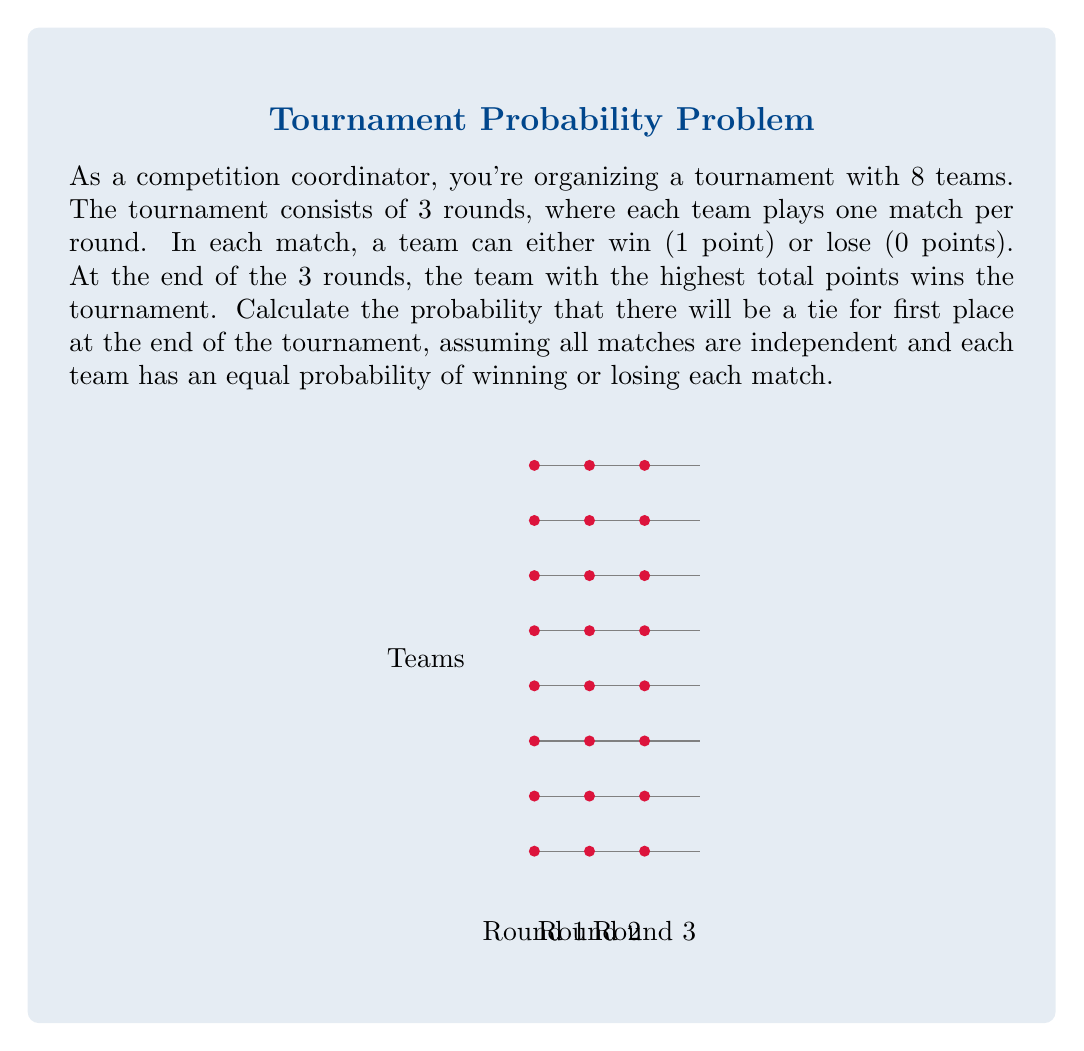Could you help me with this problem? Let's approach this step-by-step:

1) First, we need to understand the possible outcomes. After 3 rounds, a team can have 0, 1, 2, or 3 points.

2) For a tie to occur, at least two teams must have the highest score, and no team can have a higher score.

3) The probability of a team getting exactly k points in 3 rounds follows a binomial distribution:

   $P(X=k) = \binom{3}{k} (0.5)^3 = \binom{3}{k} (0.125)$

4) The probabilities for each outcome are:
   $P(0) = P(3) = 0.125$
   $P(1) = P(2) = 0.375$

5) Now, we need to consider the ways a tie can occur:
   - All teams tie with 3 points
   - All teams tie with 2 points
   - All teams tie with 1 point
   - All teams tie with 0 points
   - Some teams tie with 3 points (2 or more, but not all)
   - Some teams tie with 2 points (2 or more, but not all)
   - Some teams tie with 1 point (2 or more, but not all)
   - Some teams tie with 0 points (2 or more, but not all)

6) Let's calculate these probabilities:
   
   $P(\text{all 3}) = 0.125^8 = 5.96 \times 10^{-8}$
   $P(\text{all 2}) = P(\text{all 1}) = 0.375^8 = 1.53 \times 10^{-4}$
   $P(\text{all 0}) = 0.125^8 = 5.96 \times 10^{-8}$

7) For ties with some (but not all) teams:

   $P(\text{some 3}) = \sum_{k=2}^7 \binom{8}{k} 0.125^k (0.875)^{8-k} = 0.00284$
   $P(\text{some 2}) = P(\text{some 1}) = \sum_{k=2}^7 \binom{8}{k} 0.375^k (0.625)^{8-k} = 0.22656$
   $P(\text{some 0}) = \sum_{k=2}^7 \binom{8}{k} 0.125^k (0.875)^{8-k} = 0.00284$

8) The total probability of a tie is the sum of all these probabilities:

   $P(\text{tie}) = (5.96 \times 10^{-8}) + (1.53 \times 10^{-4}) + (1.53 \times 10^{-4}) + (5.96 \times 10^{-8}) + 0.00284 + 0.22656 + 0.22656 + 0.00284$

9) Simplifying:

   $P(\text{tie}) = 0.45896$

Therefore, the probability of a tie occurring is approximately 0.45896 or about 45.896%.
Answer: $0.45896$ 